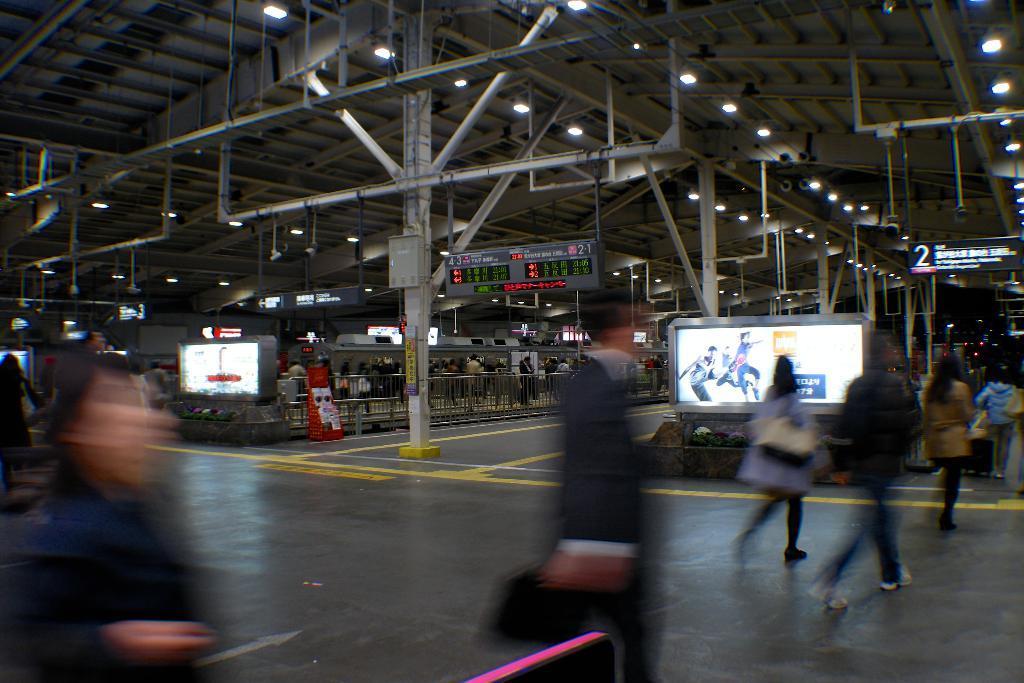In one or two sentences, can you explain what this image depicts? In this picture, on the right side there is a screen and near the screen people are walking and in the middle there is a pillar made up of some material. 